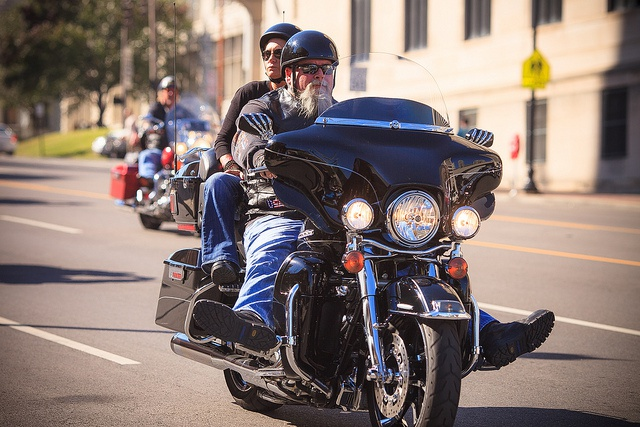Describe the objects in this image and their specific colors. I can see motorcycle in gray, black, navy, and darkgray tones, people in gray, black, white, and darkgray tones, people in gray, black, navy, and lightgray tones, motorcycle in gray, darkgray, lightgray, and maroon tones, and motorcycle in gray, black, darkgray, and lightgray tones in this image. 